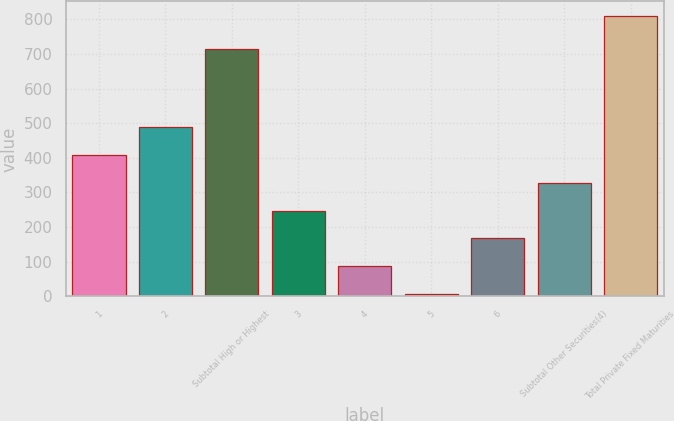<chart> <loc_0><loc_0><loc_500><loc_500><bar_chart><fcel>1<fcel>2<fcel>Subtotal High or Highest<fcel>3<fcel>4<fcel>5<fcel>6<fcel>Subtotal Other Securities(4)<fcel>Total Private Fixed Maturities<nl><fcel>408.5<fcel>489<fcel>713<fcel>247.5<fcel>86.5<fcel>6<fcel>167<fcel>328<fcel>811<nl></chart> 